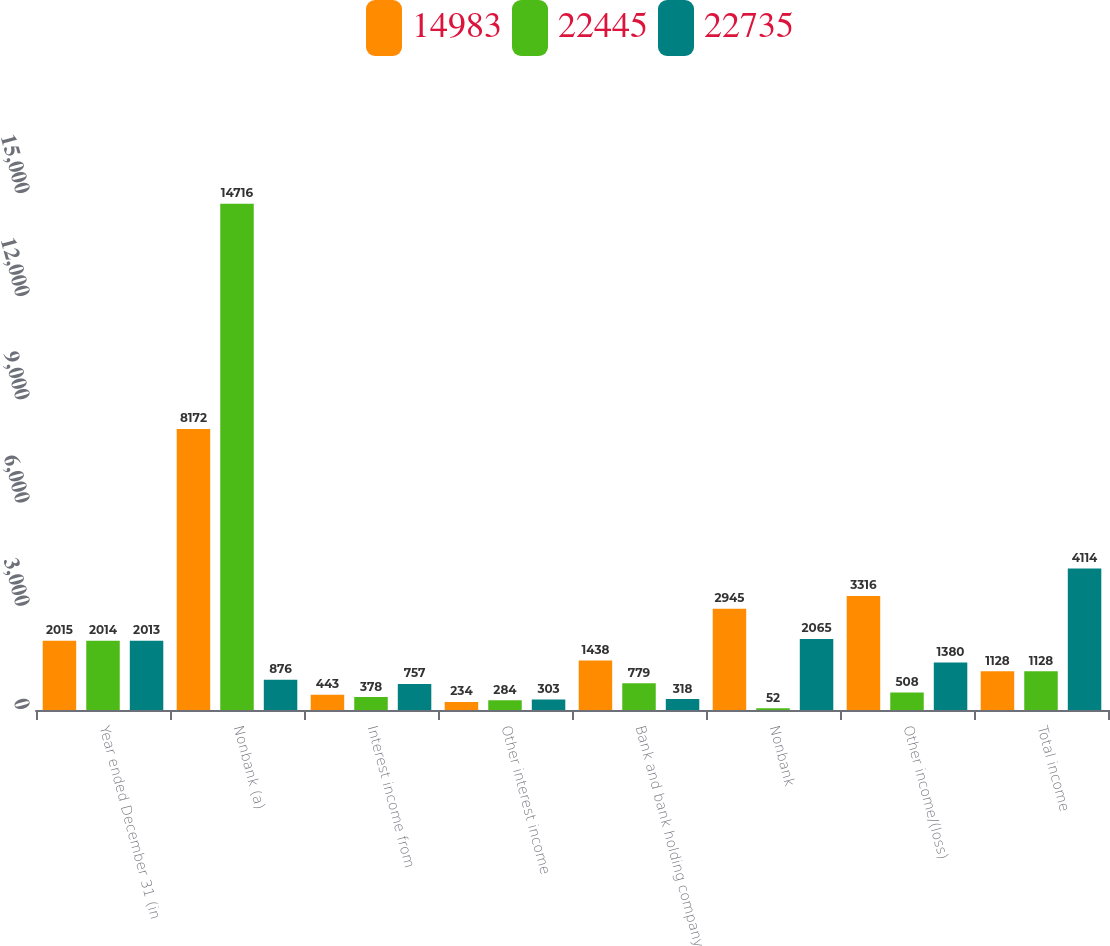<chart> <loc_0><loc_0><loc_500><loc_500><stacked_bar_chart><ecel><fcel>Year ended December 31 (in<fcel>Nonbank (a)<fcel>Interest income from<fcel>Other interest income<fcel>Bank and bank holding company<fcel>Nonbank<fcel>Other income/(loss)<fcel>Total income<nl><fcel>14983<fcel>2015<fcel>8172<fcel>443<fcel>234<fcel>1438<fcel>2945<fcel>3316<fcel>1128<nl><fcel>22445<fcel>2014<fcel>14716<fcel>378<fcel>284<fcel>779<fcel>52<fcel>508<fcel>1128<nl><fcel>22735<fcel>2013<fcel>876<fcel>757<fcel>303<fcel>318<fcel>2065<fcel>1380<fcel>4114<nl></chart> 